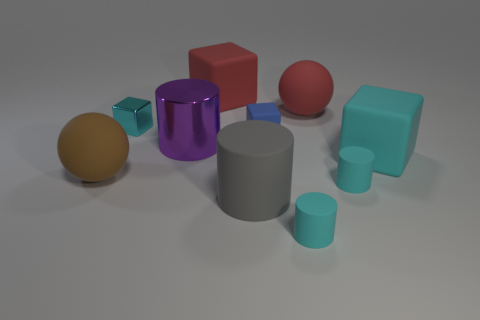Do the sphere that is to the right of the large brown matte sphere and the cyan cylinder on the left side of the large red sphere have the same size? Upon examining the spatial arrangement and relative sizes, the sphere to the right of the large brown matte sphere and the cyan cylinder to the left side of the large red sphere do not share the same dimensions. The sphere appears slightly smaller in diameter compared to the cyan cylinder, indicating a difference in size. 